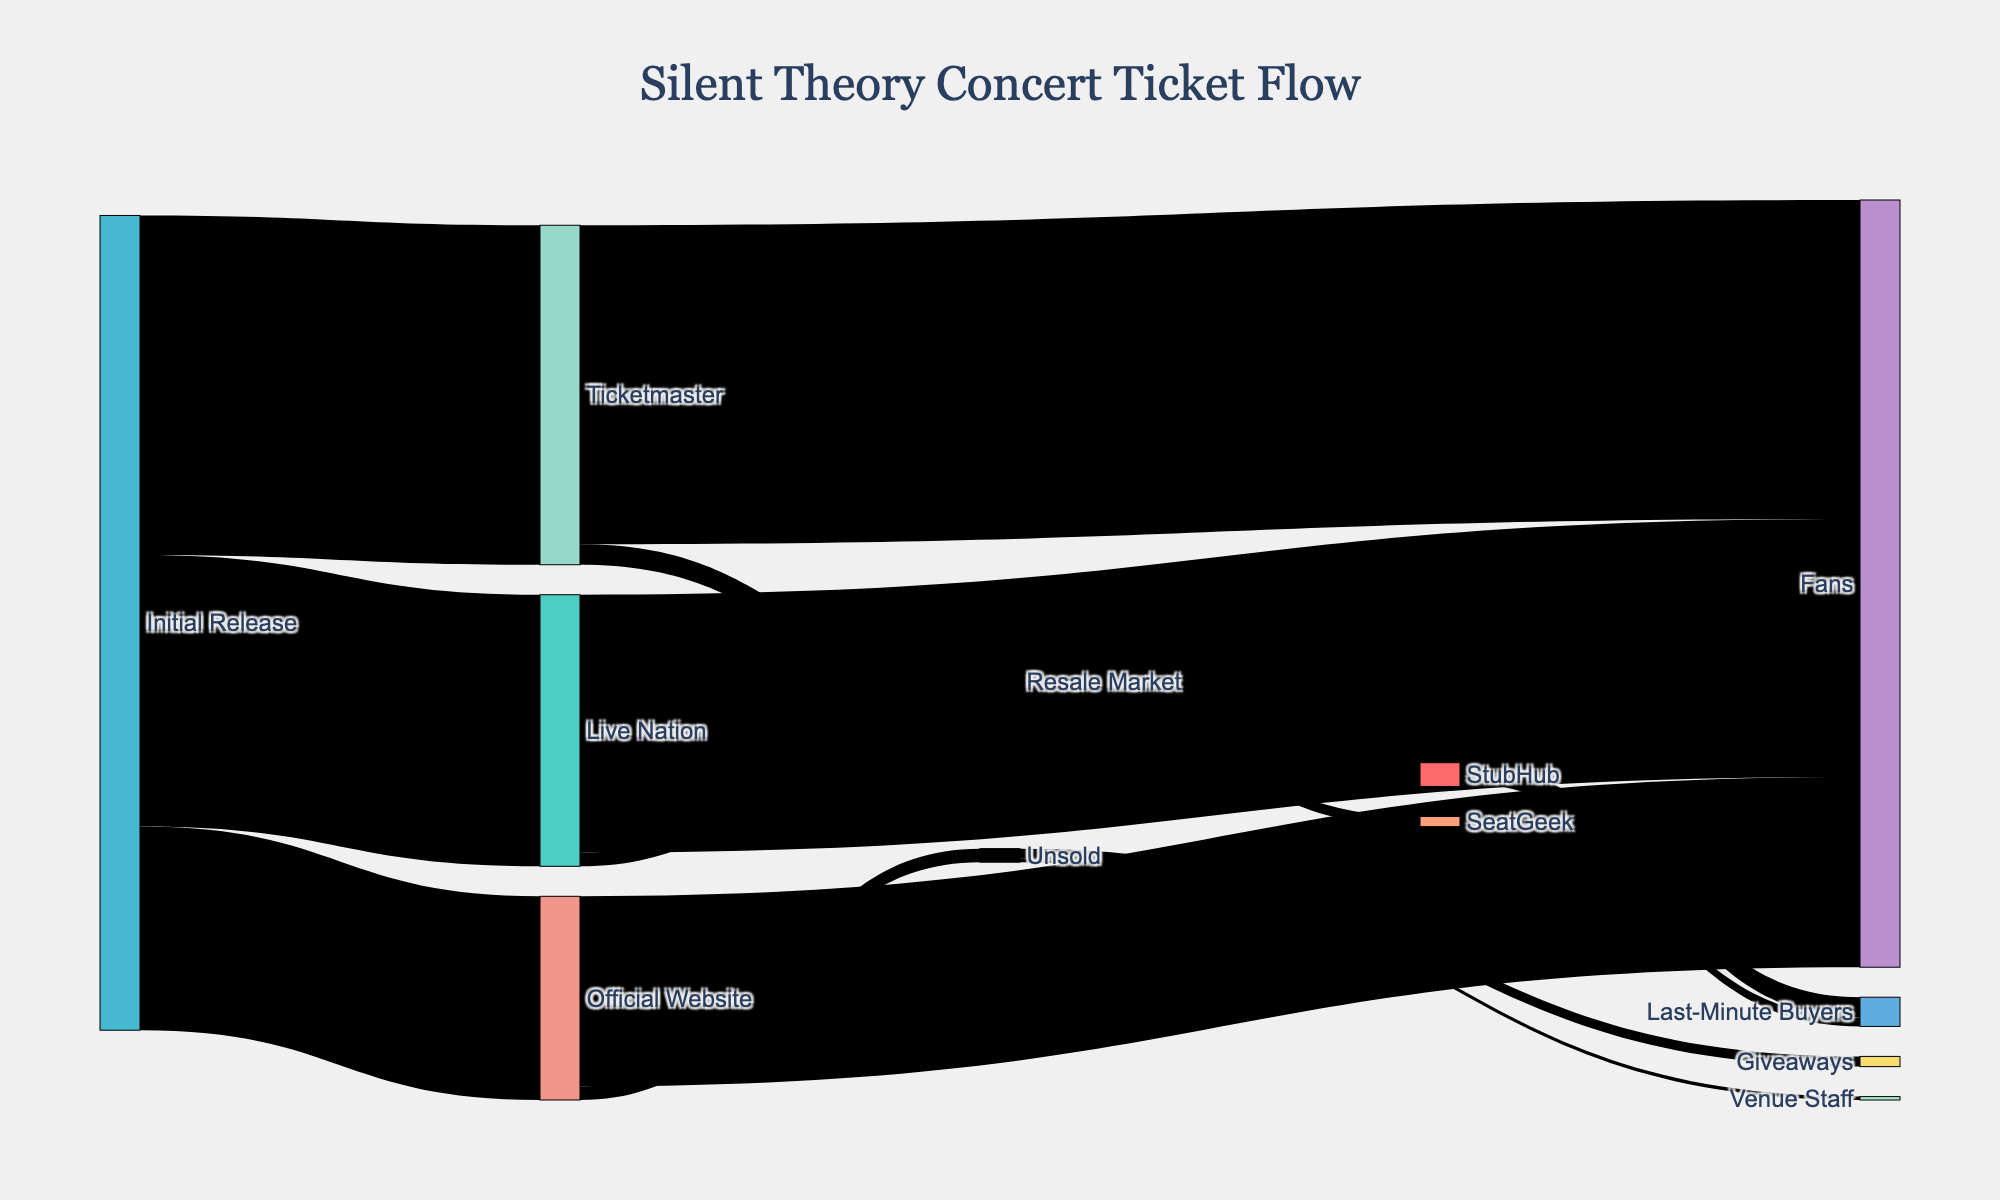What is the title of the Sankey diagram? The title is present at the top of the diagram and it provides a summary of what the diagram represents. It's labeled with a larger font size compared to other text.
Answer: Silent Theory Concert Ticket Flow How many tickets were initially released in total? To find the total number of initially released tickets, sum the values from 'Initial Release' to its child nodes: 3000 (Official Website) + 5000 (Ticketmaster) + 4000 (Live Nation).
Answer: 12000 How many tickets are unsold after the initial release? The figure shows the number of unsold tickets as a target node directly linked to 'Official Website'.
Answer: 200 Which distribution channel sold the most tickets to fans? Compare the values of tickets sold to fans among 'Official Website', 'Ticketmaster', and 'Live Nation'.
Answer: Ticketmaster What is the total number of tickets ending up on the resale market? Sum the tickets going from 'Ticketmaster' and 'Live Nation' to their respective resale markets: 300 (Ticketmaster to Resale Market) + 200 (Live Nation to Resale Market).
Answer: 500 How many tickets were given away through unsold tickets? The target node 'Giveaways' connected to 'Unsold' shows the number of tickets given as giveaways.
Answer: 150 How many tickets do StubHub and SeatGeek collectively send to last-minute buyers? Sum the values of tickets going from 'StubHub' and 'SeatGeek' to 'Last-Minute Buyers': 300 (StubHub to Last-Minute Buyers) + 130 (SeatGeek to Last-Minute Buyers).
Answer: 430 What happens to the tickets sold via the Official Website that do not reach fans? By examining the flow from 'Official Website', the unsold tickets are divided between 'Giveaways' and 'Venue Staff'.
Answer: Giveaways and Venue Staff Is the number of tickets handled by Live Nation larger than the number handled by Ticketmaster? Compare the initial values directed from 'Initial Release' to 'Ticketmaster' and 'Live Nation'.
Answer: No Where do the majority of resale market tickets end up? The largest values from 'Resale Market' nodes 'StubHub' and 'SeatGeek' going into 'Last-Minute Buyers' can be compared.
Answer: StubHub 